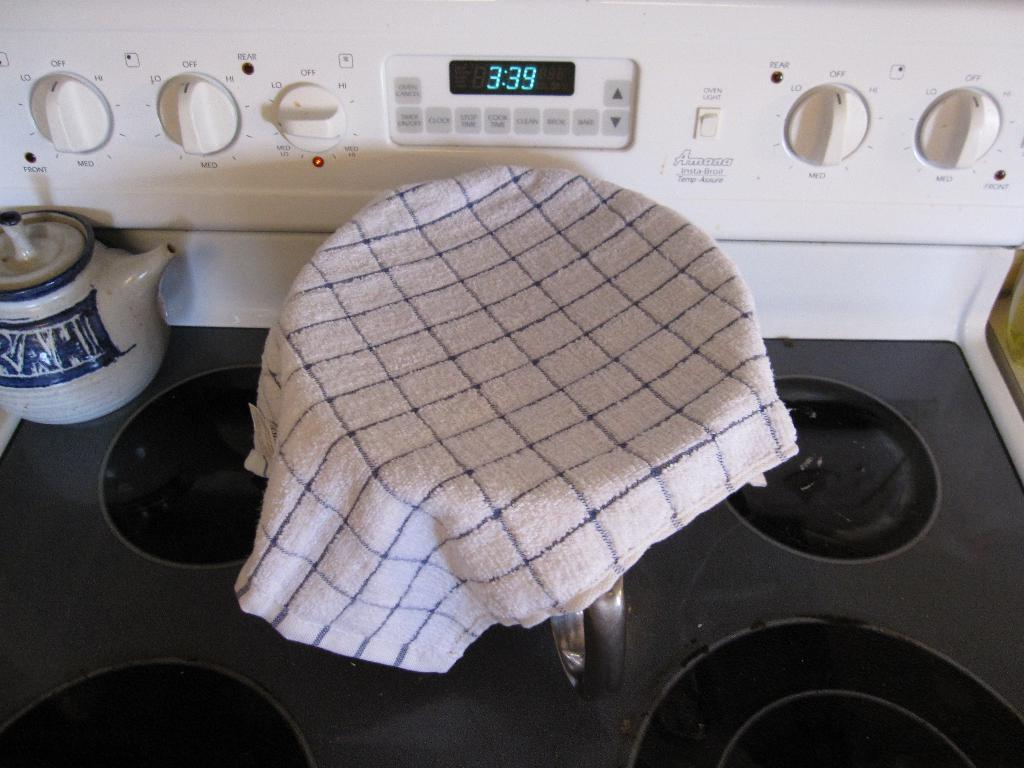Provide a one-sentence caption for the provided image. The blue-light digital clock indicates the time is 3:39. 